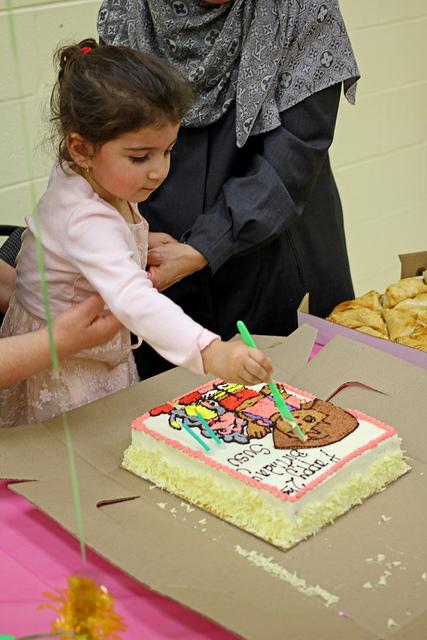What shape is this cake?
Give a very brief answer. Rectangle. Is this a birthday party?
Keep it brief. Yes. Is her dress colorful?
Keep it brief. No. Who is cutting the cake?
Short answer required. Girl. What is in the girls hand?
Answer briefly. Knife. What is on her hair?
Keep it brief. Hair tie. Who is on the cake?
Keep it brief. Dora. Are they using glue sticks?
Answer briefly. No. Who likely made this cake?
Be succinct. Bakery. How many people are in the picture?
Answer briefly. 2. What is the child cutting with scissors?
Short answer required. Cake. What does the design represent on the cake?
Be succinct. Dora. 